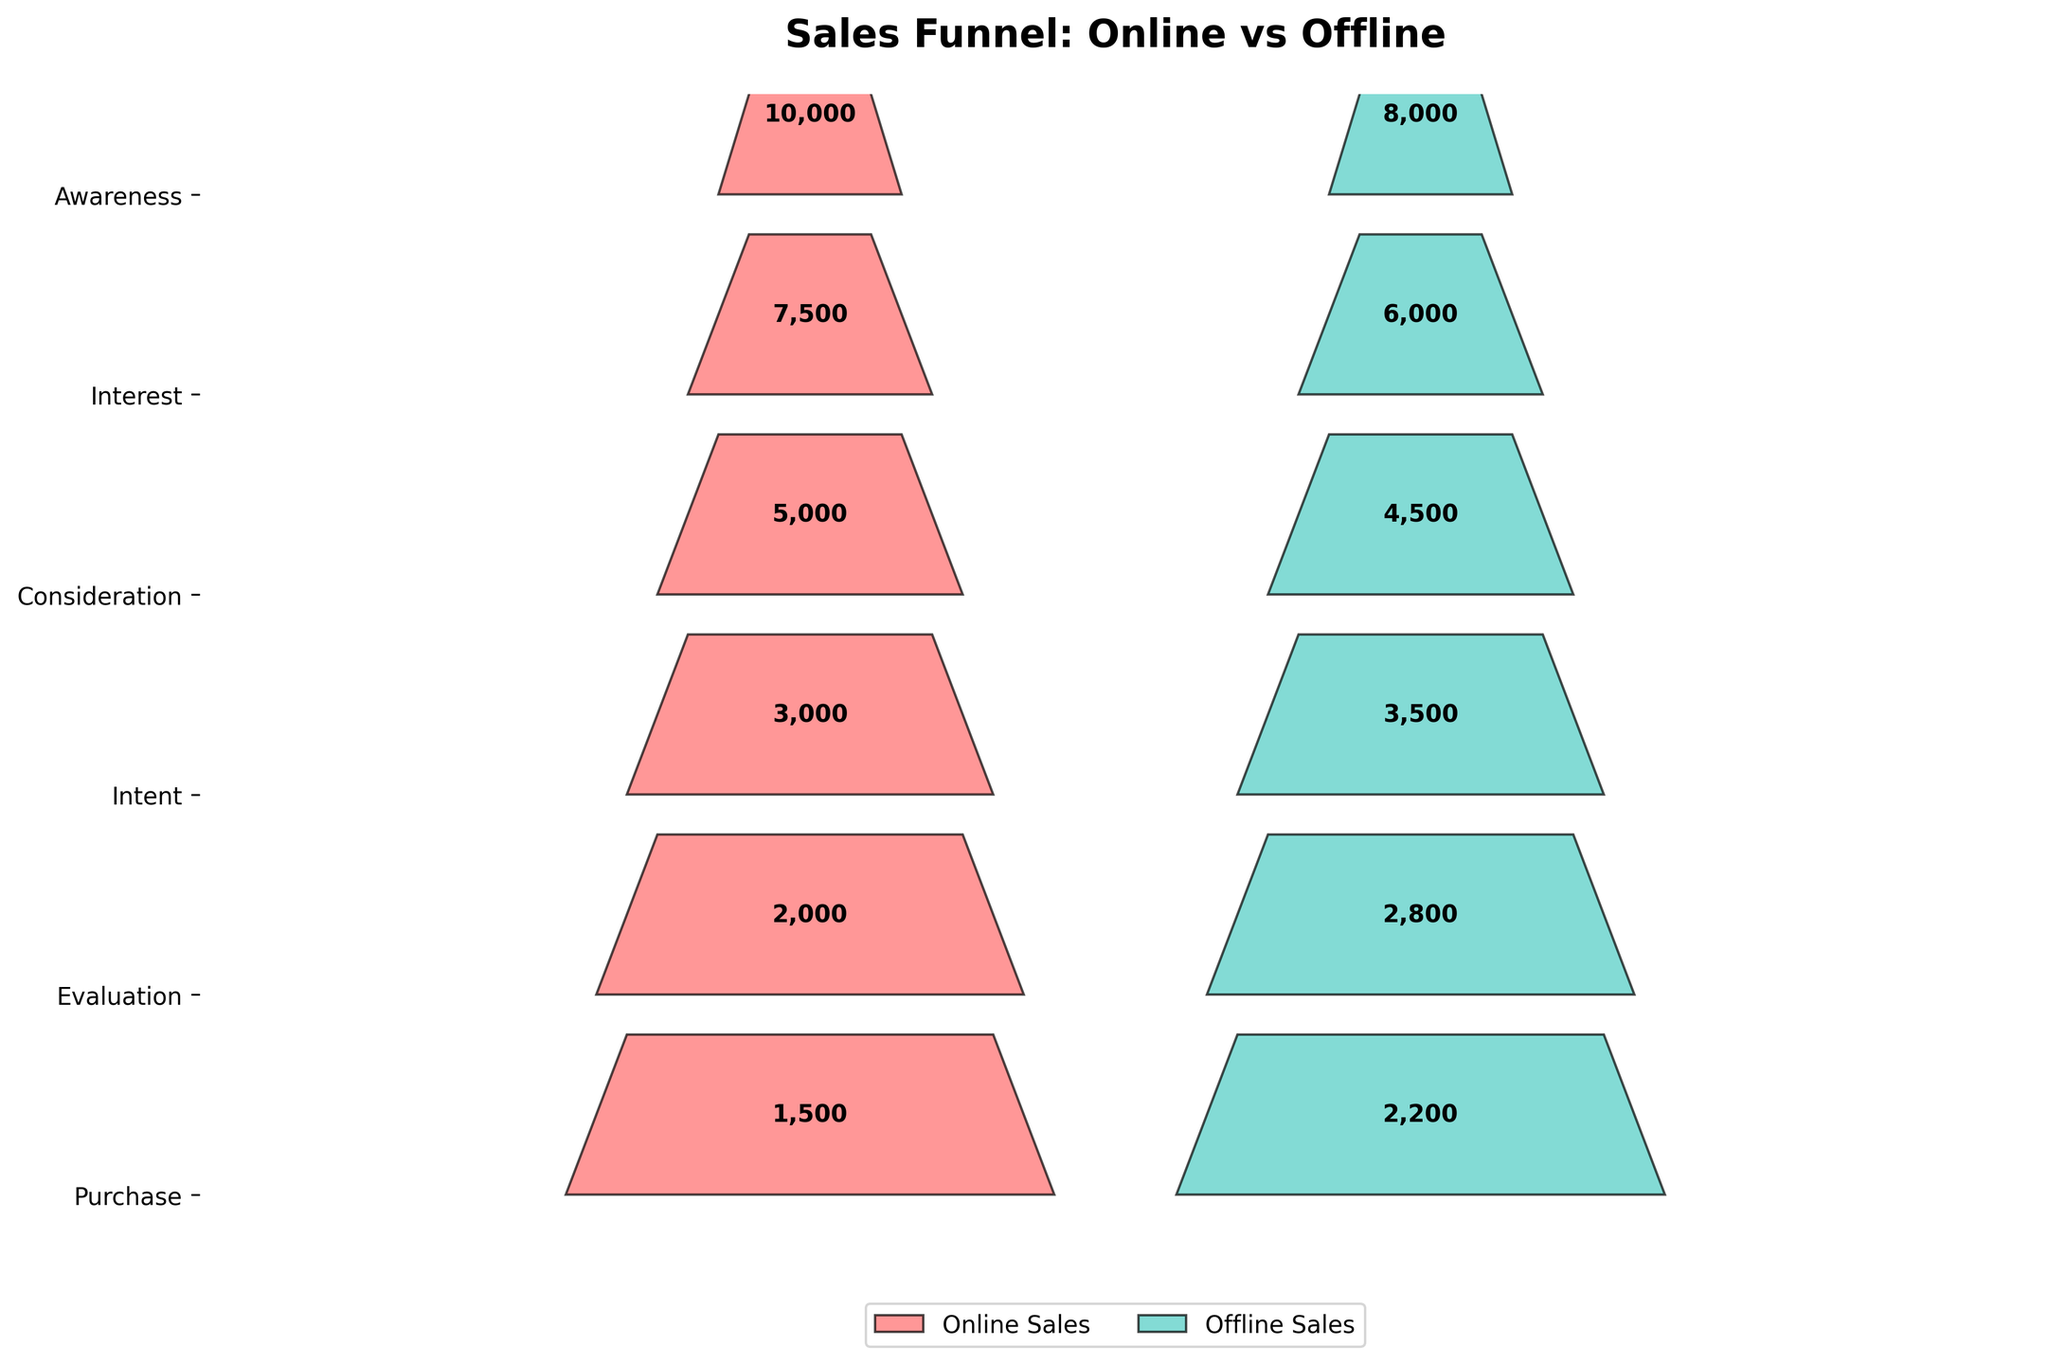How many stages are in the sales funnel? The y-axis lists the stages in the sales funnel. Count the number of stages from the plot.
Answer: 6 What is the title of the plot? The title is displayed at the top center of the plot.
Answer: Sales Funnel: Online vs Offline What color represents online sales? Observe the legend below the plot. The color for online sales is mentioned along with a colored rectangle.
Answer: Red How many offline purchases were made? The 'Purchase' stage on the y-axis lists the number of offline sales as 2200.
Answer: 2200 What is the difference in online and offline sales at the 'Intent' stage? Look at the 'Intent' stage on the y-axis. The difference is calculated as 3500 (offline) - 3000 (online).
Answer: 500 How many more online 'Awareness' sales are there compared to offline? At the 'Awareness' stage, online sales are 10000 and offline sales are 8000. The difference is 10000 - 8000.
Answer: 2000 Which stage has more offline purchases than online? Compare offline and online numbers across all stages. The 'Intent', 'Evaluation', and 'Purchase' stages have more offline purchases.
Answer: Intent, Evaluation, Purchase Which stage has the smallest difference between online and offline sales? Calculate the absolute differences for each stage and the smallest one is for the 'Evaluation' stage, which is
Answer: 800 What is the sum of online 'Interest' and 'Consideration' sales? Add the numbers for 'Interest' (7500) and 'Consideration' (5000) sales.
Answer: 12500 Which stage has the largest proportion of sales retained from the previous stage for offline sales? To find the stage, calculate the relative proportions. From 'Intent' (3500) to 'Evaluation' (2800) there is a retention proportion of 2800/3500. This is the highest
Answer: Evaluation 